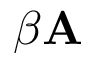Convert formula to latex. <formula><loc_0><loc_0><loc_500><loc_500>\beta A</formula> 